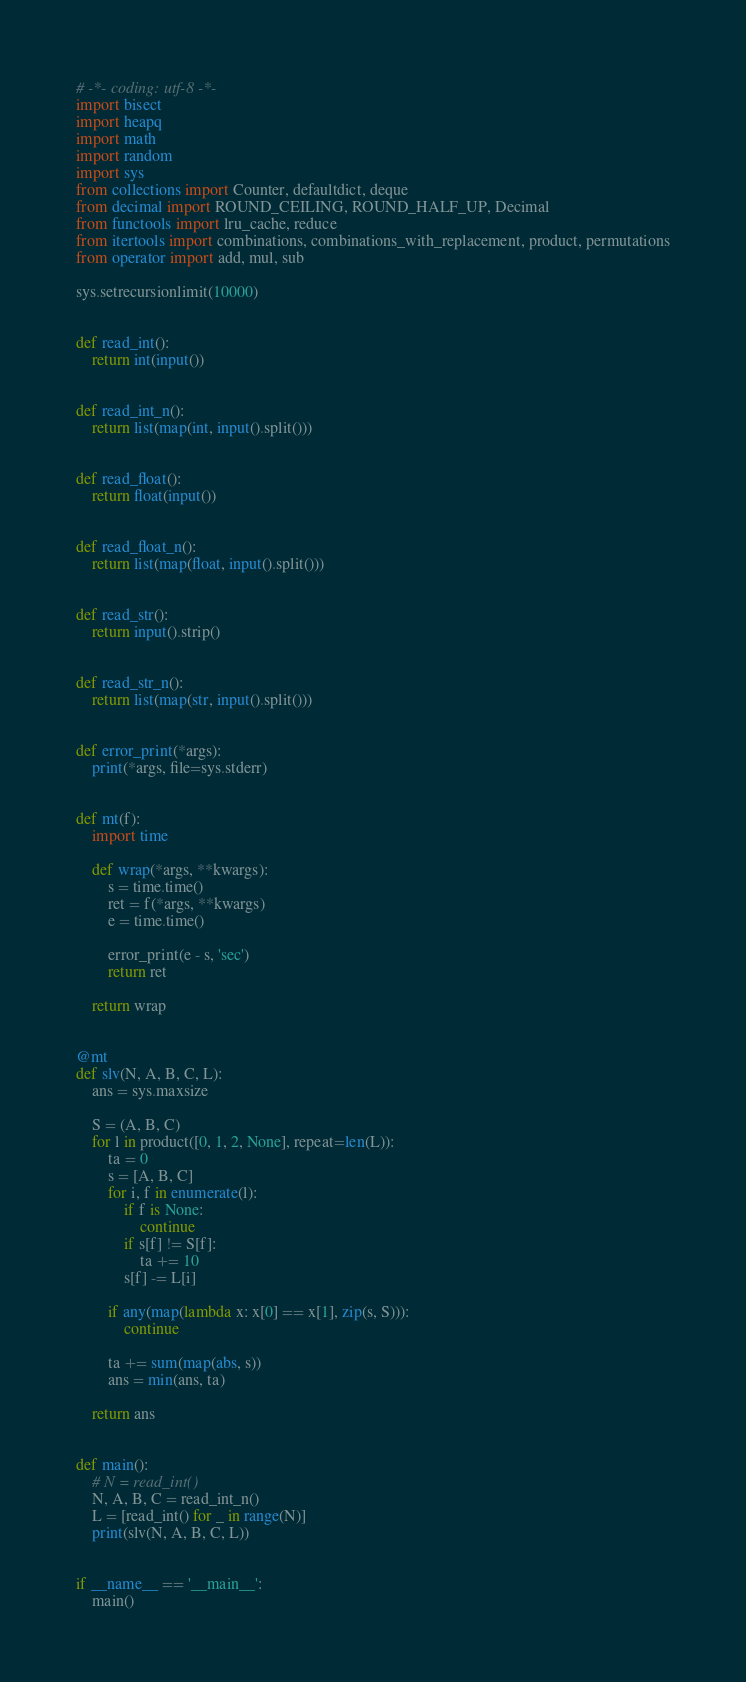Convert code to text. <code><loc_0><loc_0><loc_500><loc_500><_Python_># -*- coding: utf-8 -*-
import bisect
import heapq
import math
import random
import sys
from collections import Counter, defaultdict, deque
from decimal import ROUND_CEILING, ROUND_HALF_UP, Decimal
from functools import lru_cache, reduce
from itertools import combinations, combinations_with_replacement, product, permutations
from operator import add, mul, sub

sys.setrecursionlimit(10000)


def read_int():
    return int(input())


def read_int_n():
    return list(map(int, input().split()))


def read_float():
    return float(input())


def read_float_n():
    return list(map(float, input().split()))


def read_str():
    return input().strip()


def read_str_n():
    return list(map(str, input().split()))


def error_print(*args):
    print(*args, file=sys.stderr)


def mt(f):
    import time

    def wrap(*args, **kwargs):
        s = time.time()
        ret = f(*args, **kwargs)
        e = time.time()

        error_print(e - s, 'sec')
        return ret

    return wrap


@mt
def slv(N, A, B, C, L):
    ans = sys.maxsize
    
    S = (A, B, C)
    for l in product([0, 1, 2, None], repeat=len(L)):
        ta = 0
        s = [A, B, C]
        for i, f in enumerate(l):
            if f is None:
                continue
            if s[f] != S[f]:
                ta += 10
            s[f] -= L[i]

        if any(map(lambda x: x[0] == x[1], zip(s, S))):
            continue
        
        ta += sum(map(abs, s))
        ans = min(ans, ta)

    return ans


def main():
    # N = read_int()
    N, A, B, C = read_int_n()
    L = [read_int() for _ in range(N)]
    print(slv(N, A, B, C, L))


if __name__ == '__main__':
    main()
</code> 